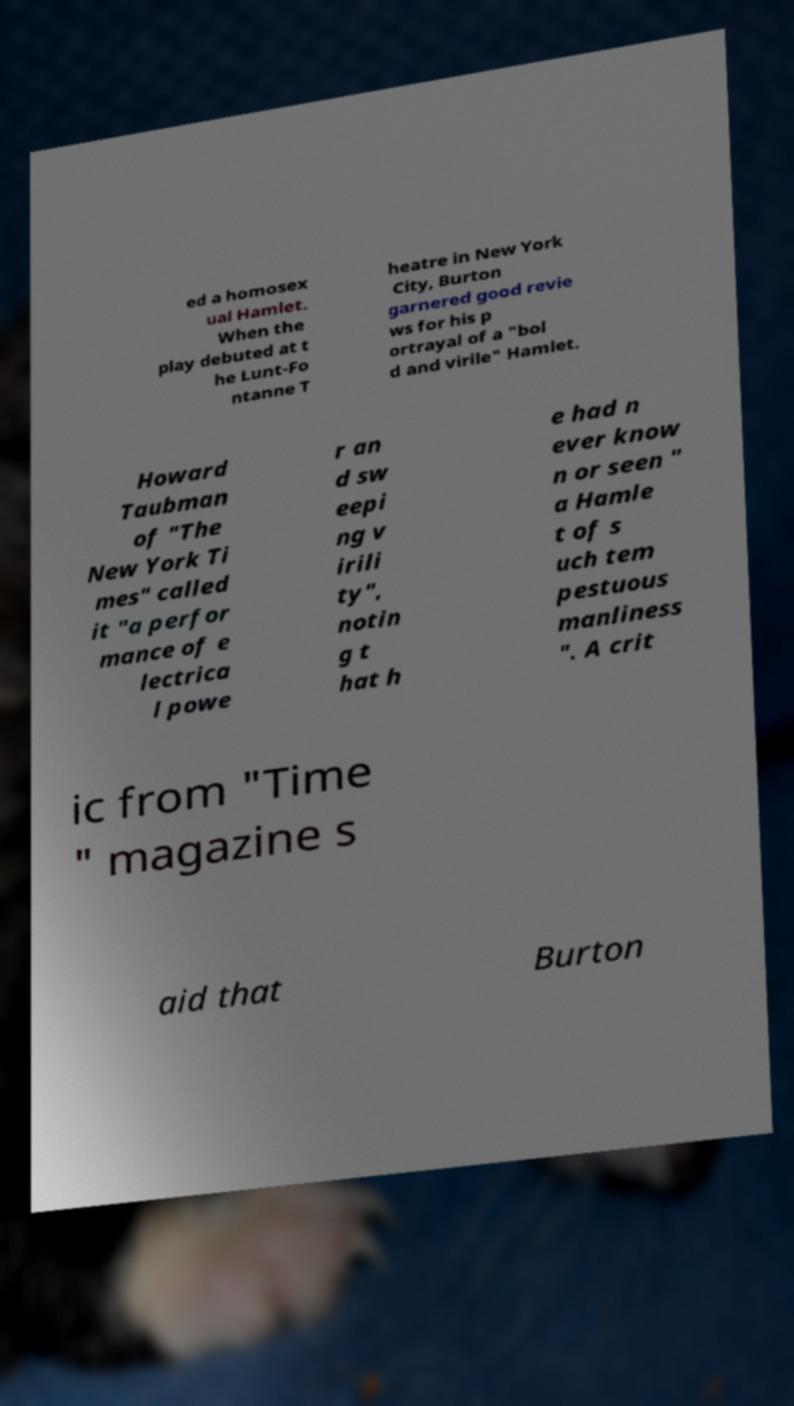Could you extract and type out the text from this image? ed a homosex ual Hamlet. When the play debuted at t he Lunt-Fo ntanne T heatre in New York City, Burton garnered good revie ws for his p ortrayal of a "bol d and virile" Hamlet. Howard Taubman of "The New York Ti mes" called it "a perfor mance of e lectrica l powe r an d sw eepi ng v irili ty", notin g t hat h e had n ever know n or seen " a Hamle t of s uch tem pestuous manliness ". A crit ic from "Time " magazine s aid that Burton 